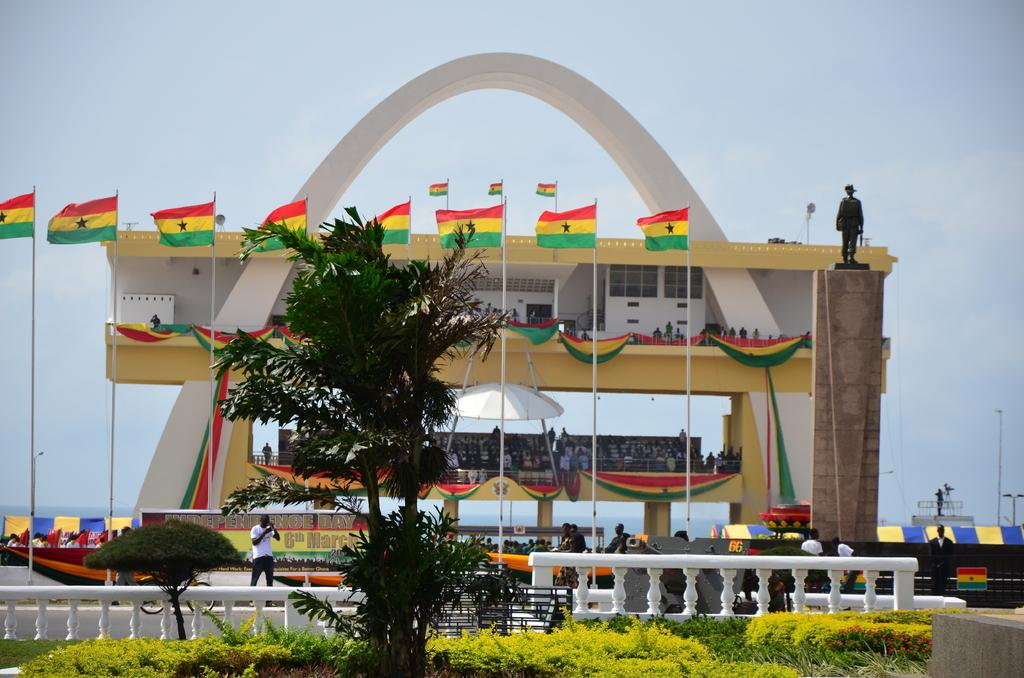What type of natural elements can be seen in the image? There are trees in the image. What man-made objects are present in the image? There are flags, a statue, fencing, an umbrella, a building, and poles in the image. What is the color of the sky in the image? The sky is visible in the image, and it has a white and blue color. What type of truck can be seen parked near the building in the image? There is no truck present in the image; it only features trees, flags, a statue, fencing, an umbrella, a building, and poles. Can you tell me how many fans are visible in the image? There are no fans present in the image. 